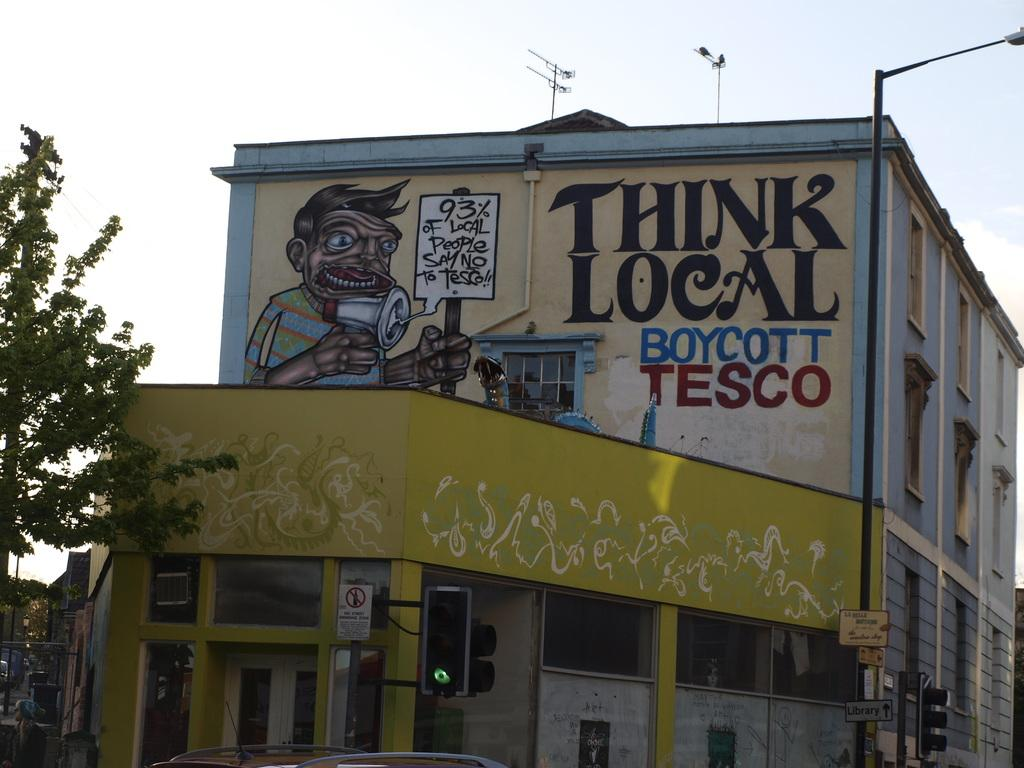What type of structures are present in the image? There are buildings in the image. What feature can be seen on the buildings? The buildings have windows. What is visible at the top of the image? The sky is visible at the top of the image. What type of vegetation is on the left side of the image? There is a tree on the left side of the image. What type of quince-based attraction can be seen in the image? There is no quince-based attraction present in the image. How many people have died in the image? There are no people or deaths depicted in the image. 